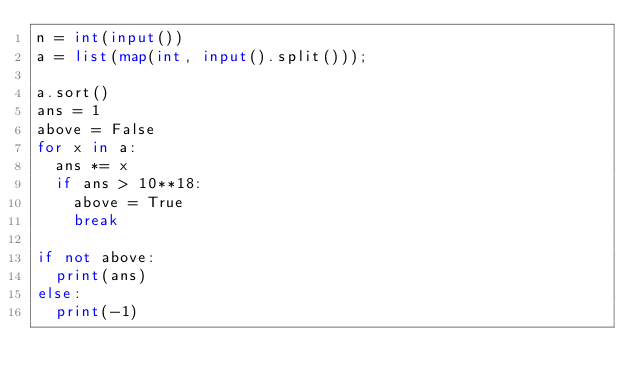Convert code to text. <code><loc_0><loc_0><loc_500><loc_500><_Python_>n = int(input())
a = list(map(int, input().split()));

a.sort()
ans = 1
above = False
for x in a:
	ans *= x
	if ans > 10**18:
		above = True
		break

if not above:
	print(ans)
else:
	print(-1)</code> 